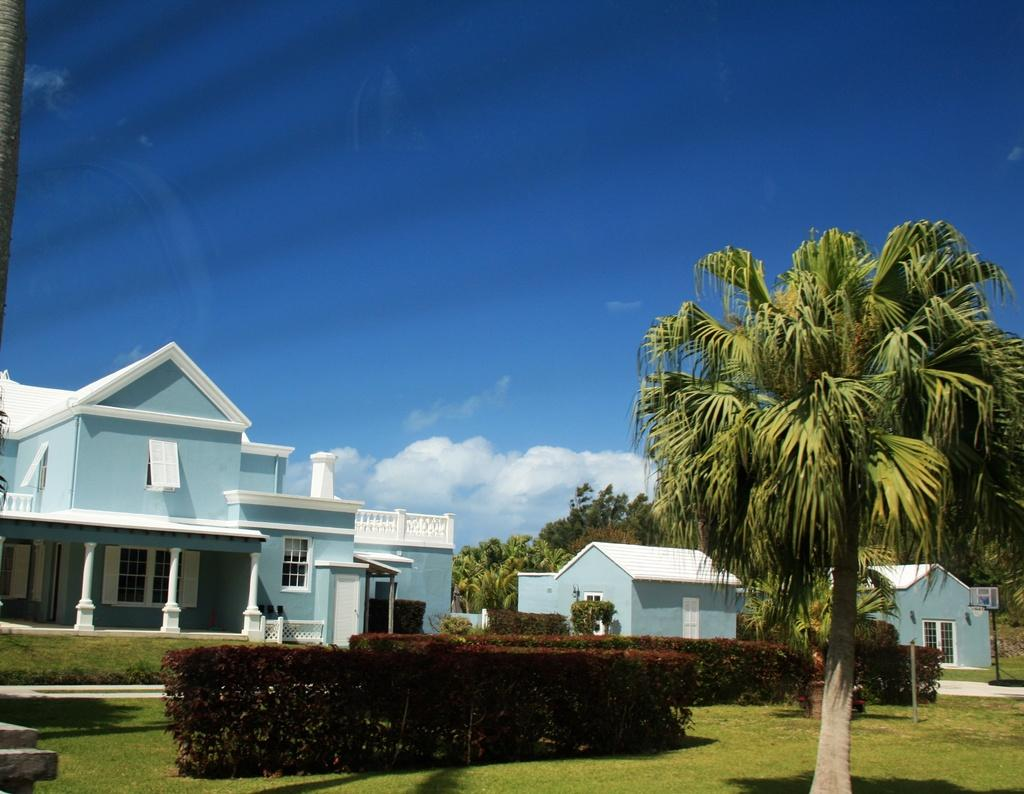What type of structures can be seen in the image? There are houses in the image. What feature do the houses have? The houses have windows. What type of vegetation is present in the image? There are trees and small plants in the image. What recreational object can be seen in the image? There is a basketball goal post in the image. What is the color of the sky in the image? The sky is blue and white in color. How many trucks are parked near the houses in the image? There are no trucks present in the image. What type of pollution can be seen in the image? There is no pollution visible in the image. 